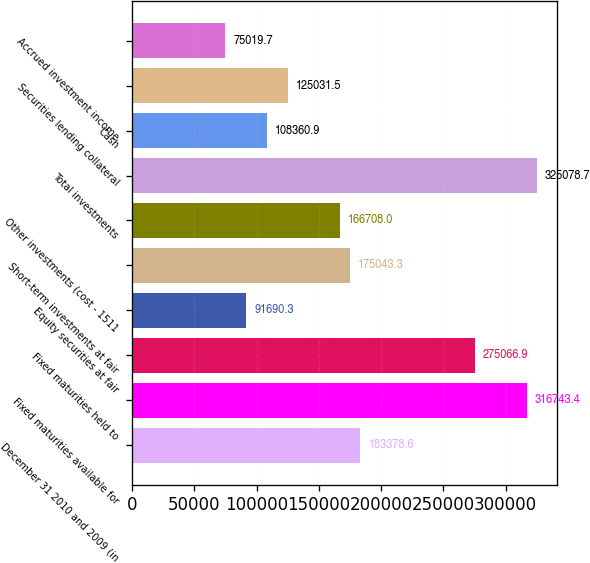Convert chart. <chart><loc_0><loc_0><loc_500><loc_500><bar_chart><fcel>December 31 2010 and 2009 (in<fcel>Fixed maturities available for<fcel>Fixed maturities held to<fcel>Equity securities at fair<fcel>Short-term investments at fair<fcel>Other investments (cost - 1511<fcel>Total investments<fcel>Cash<fcel>Securities lending collateral<fcel>Accrued investment income<nl><fcel>183379<fcel>316743<fcel>275067<fcel>91690.3<fcel>175043<fcel>166708<fcel>325079<fcel>108361<fcel>125032<fcel>75019.7<nl></chart> 